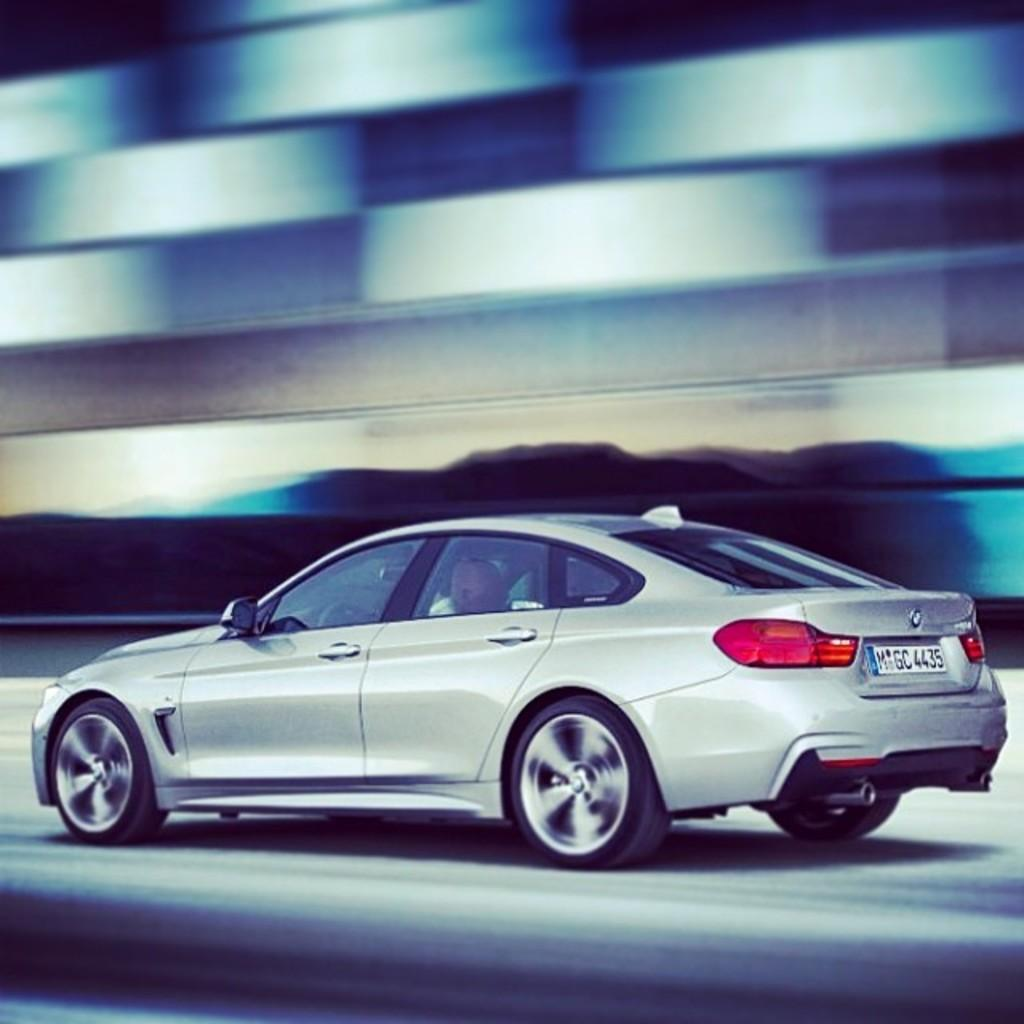What type of vehicle is in the image? There is a gray color vehicle in the image. Where is the vehicle located? The vehicle is on the road. Can you describe the background of the image? The background of the image is blurred. What type of powder is being tested in the image? There is no powder or testing activity present in the image; it features a gray color vehicle on the road with a blurred background. 